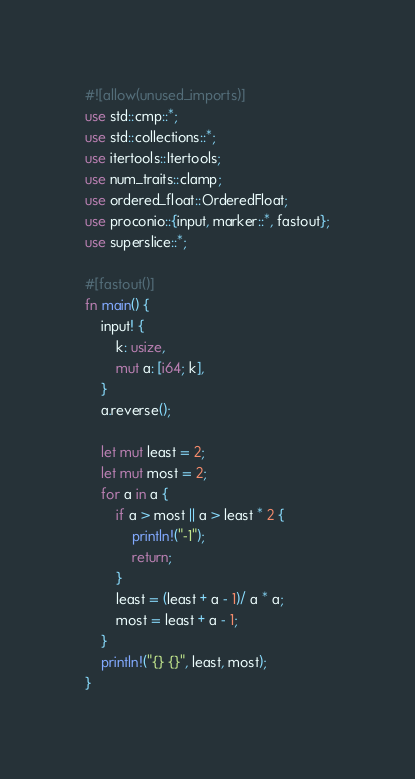Convert code to text. <code><loc_0><loc_0><loc_500><loc_500><_Rust_>#![allow(unused_imports)]
use std::cmp::*;
use std::collections::*;
use itertools::Itertools;
use num_traits::clamp;
use ordered_float::OrderedFloat;
use proconio::{input, marker::*, fastout};
use superslice::*;

#[fastout()]
fn main() {
    input! {
        k: usize,
        mut a: [i64; k],
    }
    a.reverse();

    let mut least = 2;
    let mut most = 2;
    for a in a {
        if a > most || a > least * 2 {
            println!("-1");
            return;
        }
        least = (least + a - 1)/ a * a;
        most = least + a - 1;
    }
    println!("{} {}", least, most);
}
</code> 